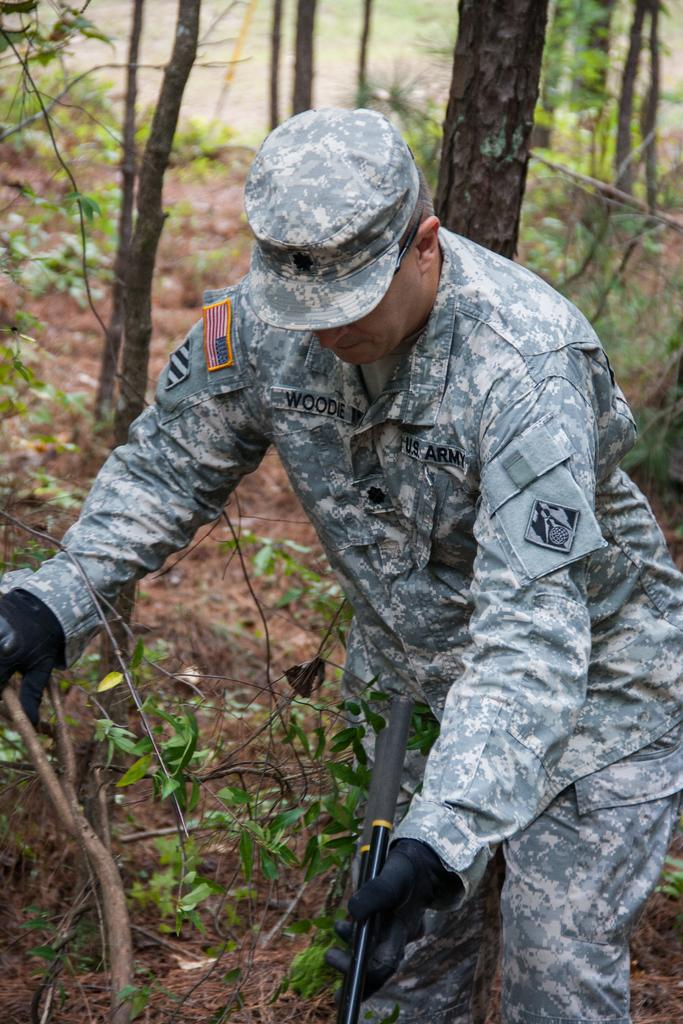What is the main subject of the image? There is a person in the image. What type of clothing is the person wearing? The person is wearing an army uniform. What accessories is the person wearing? The person is wearing a cap and gloves. What is the person holding in their hands? The person is holding sticks in their hands. What type of vegetation can be seen in the image? There are plants and trees in the image. Can you tell me how many plots are visible in the image? There is no reference to a plot in the image; it features a person wearing an army uniform, holding sticks, and surrounded by plants and trees. What type of copy is the person holding in their hands? The person is not holding any copy; they are holding sticks in their hands. 